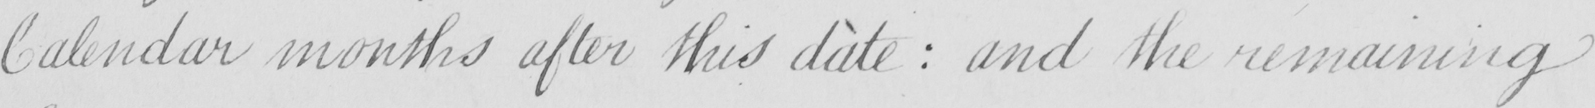Can you read and transcribe this handwriting? Calendar months after this date  :  and the remaining 